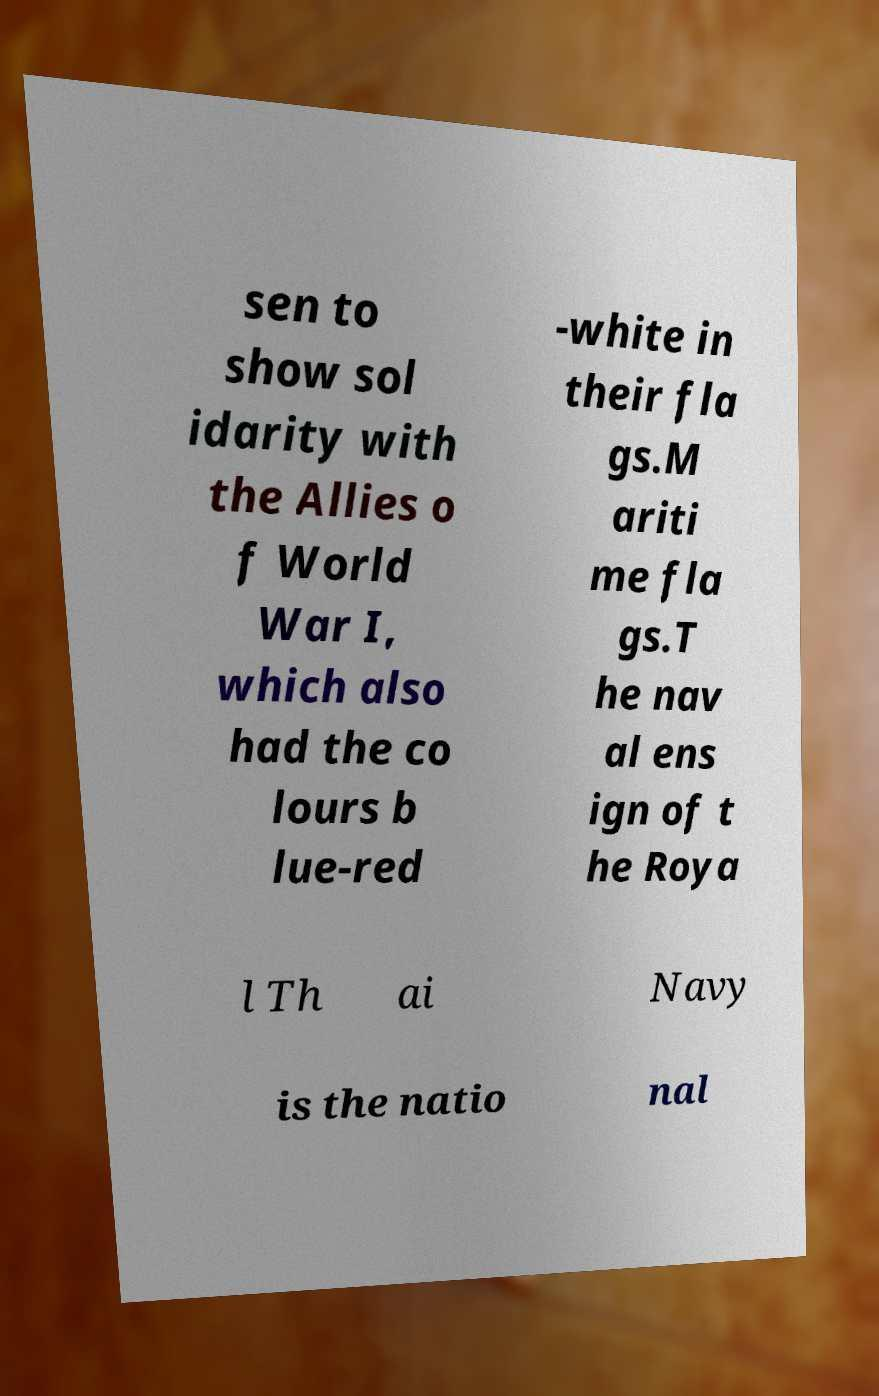Could you extract and type out the text from this image? sen to show sol idarity with the Allies o f World War I, which also had the co lours b lue-red -white in their fla gs.M ariti me fla gs.T he nav al ens ign of t he Roya l Th ai Navy is the natio nal 